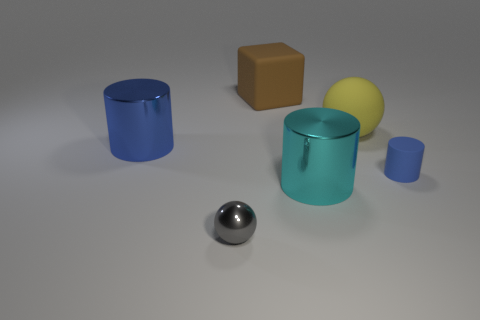Subtract all small matte cylinders. How many cylinders are left? 2 Add 4 large cyan metallic spheres. How many objects exist? 10 Subtract all spheres. How many objects are left? 4 Subtract 2 spheres. How many spheres are left? 0 Subtract all cyan blocks. Subtract all brown cylinders. How many blocks are left? 1 Subtract all gray balls. How many blue cylinders are left? 2 Subtract all cyan cylinders. Subtract all brown matte cubes. How many objects are left? 4 Add 4 balls. How many balls are left? 6 Add 2 cyan metallic objects. How many cyan metallic objects exist? 3 Subtract all cyan cylinders. How many cylinders are left? 2 